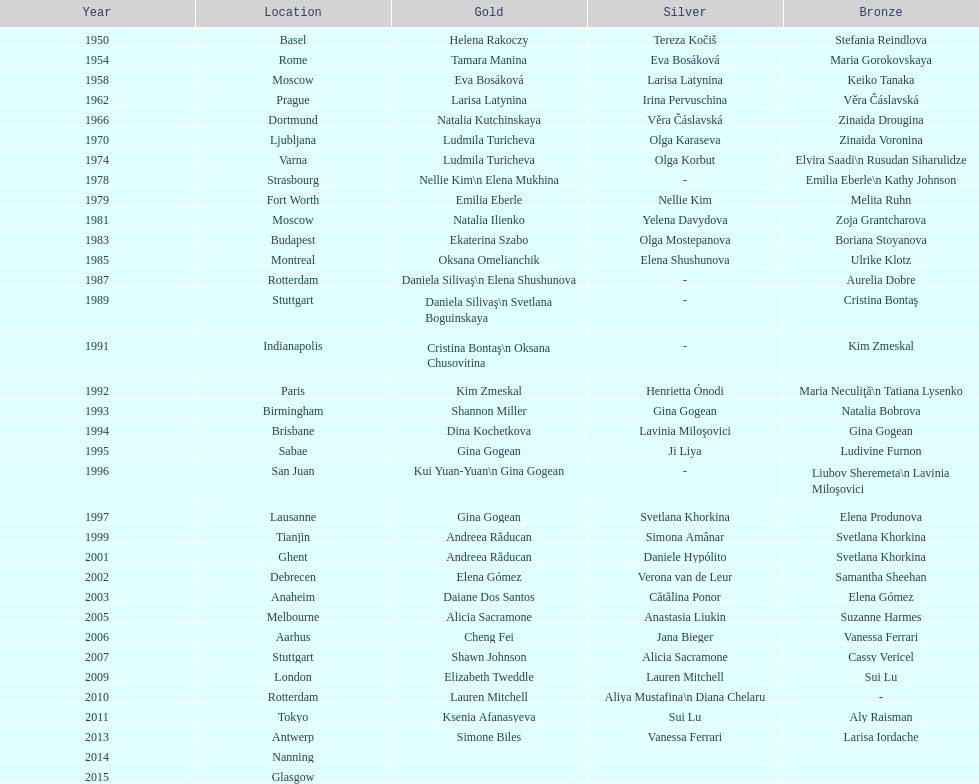What is the aggregate amount of russian gymnasts who have obtained silver? 8. 